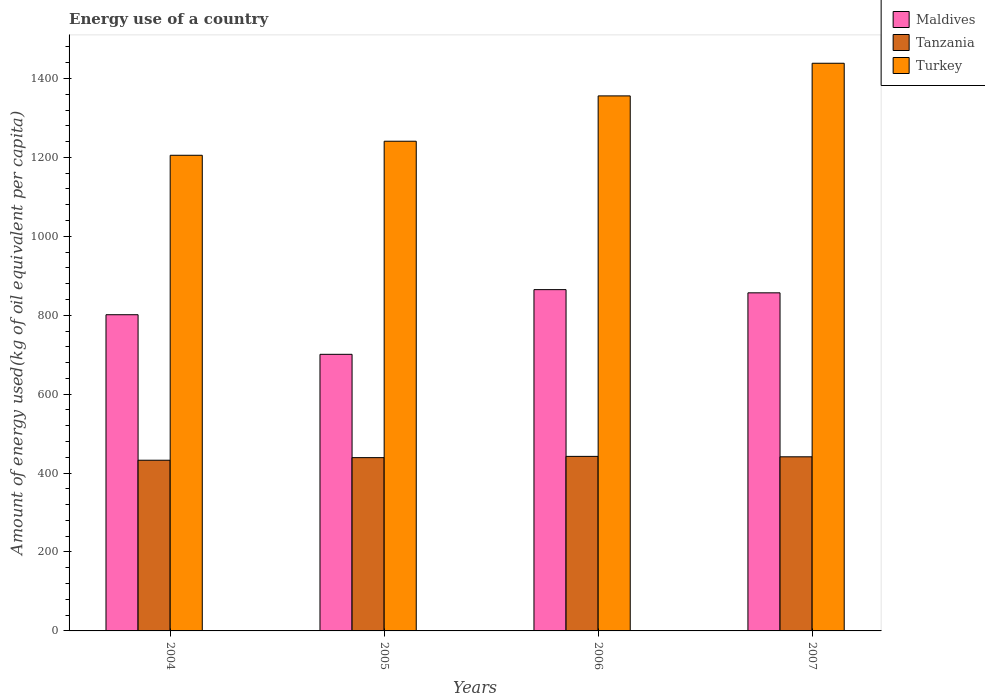How many different coloured bars are there?
Offer a very short reply. 3. How many groups of bars are there?
Ensure brevity in your answer.  4. Are the number of bars on each tick of the X-axis equal?
Provide a short and direct response. Yes. What is the label of the 2nd group of bars from the left?
Your response must be concise. 2005. What is the amount of energy used in in Tanzania in 2004?
Offer a very short reply. 432.58. Across all years, what is the maximum amount of energy used in in Turkey?
Give a very brief answer. 1438.52. Across all years, what is the minimum amount of energy used in in Turkey?
Ensure brevity in your answer.  1205.34. In which year was the amount of energy used in in Turkey maximum?
Make the answer very short. 2007. What is the total amount of energy used in in Maldives in the graph?
Offer a terse response. 3223.82. What is the difference between the amount of energy used in in Maldives in 2006 and that in 2007?
Give a very brief answer. 8.13. What is the difference between the amount of energy used in in Tanzania in 2007 and the amount of energy used in in Maldives in 2005?
Provide a succinct answer. -259.72. What is the average amount of energy used in in Maldives per year?
Give a very brief answer. 805.95. In the year 2005, what is the difference between the amount of energy used in in Maldives and amount of energy used in in Tanzania?
Make the answer very short. 261.8. In how many years, is the amount of energy used in in Turkey greater than 1040 kg?
Ensure brevity in your answer.  4. What is the ratio of the amount of energy used in in Turkey in 2006 to that in 2007?
Your response must be concise. 0.94. Is the amount of energy used in in Turkey in 2004 less than that in 2006?
Make the answer very short. Yes. Is the difference between the amount of energy used in in Maldives in 2004 and 2005 greater than the difference between the amount of energy used in in Tanzania in 2004 and 2005?
Your response must be concise. Yes. What is the difference between the highest and the second highest amount of energy used in in Tanzania?
Your response must be concise. 1.09. What is the difference between the highest and the lowest amount of energy used in in Turkey?
Provide a short and direct response. 233.18. In how many years, is the amount of energy used in in Turkey greater than the average amount of energy used in in Turkey taken over all years?
Provide a short and direct response. 2. What does the 2nd bar from the right in 2004 represents?
Offer a terse response. Tanzania. Is it the case that in every year, the sum of the amount of energy used in in Maldives and amount of energy used in in Turkey is greater than the amount of energy used in in Tanzania?
Make the answer very short. Yes. How many bars are there?
Keep it short and to the point. 12. Are all the bars in the graph horizontal?
Keep it short and to the point. No. Are the values on the major ticks of Y-axis written in scientific E-notation?
Provide a short and direct response. No. Does the graph contain any zero values?
Your answer should be very brief. No. Does the graph contain grids?
Keep it short and to the point. No. Where does the legend appear in the graph?
Offer a terse response. Top right. How are the legend labels stacked?
Make the answer very short. Vertical. What is the title of the graph?
Your response must be concise. Energy use of a country. Does "Senegal" appear as one of the legend labels in the graph?
Provide a short and direct response. No. What is the label or title of the X-axis?
Provide a short and direct response. Years. What is the label or title of the Y-axis?
Offer a terse response. Amount of energy used(kg of oil equivalent per capita). What is the Amount of energy used(kg of oil equivalent per capita) in Maldives in 2004?
Your answer should be compact. 801.28. What is the Amount of energy used(kg of oil equivalent per capita) of Tanzania in 2004?
Offer a terse response. 432.58. What is the Amount of energy used(kg of oil equivalent per capita) of Turkey in 2004?
Ensure brevity in your answer.  1205.34. What is the Amount of energy used(kg of oil equivalent per capita) in Maldives in 2005?
Ensure brevity in your answer.  700.93. What is the Amount of energy used(kg of oil equivalent per capita) of Tanzania in 2005?
Keep it short and to the point. 439.14. What is the Amount of energy used(kg of oil equivalent per capita) in Turkey in 2005?
Make the answer very short. 1240.95. What is the Amount of energy used(kg of oil equivalent per capita) in Maldives in 2006?
Offer a terse response. 864.86. What is the Amount of energy used(kg of oil equivalent per capita) in Tanzania in 2006?
Offer a terse response. 442.3. What is the Amount of energy used(kg of oil equivalent per capita) in Turkey in 2006?
Give a very brief answer. 1355.8. What is the Amount of energy used(kg of oil equivalent per capita) of Maldives in 2007?
Your response must be concise. 856.73. What is the Amount of energy used(kg of oil equivalent per capita) of Tanzania in 2007?
Your response must be concise. 441.21. What is the Amount of energy used(kg of oil equivalent per capita) of Turkey in 2007?
Your answer should be compact. 1438.52. Across all years, what is the maximum Amount of energy used(kg of oil equivalent per capita) in Maldives?
Ensure brevity in your answer.  864.86. Across all years, what is the maximum Amount of energy used(kg of oil equivalent per capita) of Tanzania?
Your answer should be compact. 442.3. Across all years, what is the maximum Amount of energy used(kg of oil equivalent per capita) of Turkey?
Your response must be concise. 1438.52. Across all years, what is the minimum Amount of energy used(kg of oil equivalent per capita) of Maldives?
Your answer should be very brief. 700.93. Across all years, what is the minimum Amount of energy used(kg of oil equivalent per capita) in Tanzania?
Ensure brevity in your answer.  432.58. Across all years, what is the minimum Amount of energy used(kg of oil equivalent per capita) in Turkey?
Offer a very short reply. 1205.34. What is the total Amount of energy used(kg of oil equivalent per capita) in Maldives in the graph?
Ensure brevity in your answer.  3223.82. What is the total Amount of energy used(kg of oil equivalent per capita) of Tanzania in the graph?
Your answer should be very brief. 1755.23. What is the total Amount of energy used(kg of oil equivalent per capita) in Turkey in the graph?
Your answer should be compact. 5240.61. What is the difference between the Amount of energy used(kg of oil equivalent per capita) of Maldives in 2004 and that in 2005?
Your answer should be compact. 100.35. What is the difference between the Amount of energy used(kg of oil equivalent per capita) of Tanzania in 2004 and that in 2005?
Your answer should be very brief. -6.56. What is the difference between the Amount of energy used(kg of oil equivalent per capita) in Turkey in 2004 and that in 2005?
Give a very brief answer. -35.61. What is the difference between the Amount of energy used(kg of oil equivalent per capita) of Maldives in 2004 and that in 2006?
Provide a short and direct response. -63.58. What is the difference between the Amount of energy used(kg of oil equivalent per capita) in Tanzania in 2004 and that in 2006?
Offer a terse response. -9.72. What is the difference between the Amount of energy used(kg of oil equivalent per capita) of Turkey in 2004 and that in 2006?
Offer a very short reply. -150.47. What is the difference between the Amount of energy used(kg of oil equivalent per capita) of Maldives in 2004 and that in 2007?
Ensure brevity in your answer.  -55.45. What is the difference between the Amount of energy used(kg of oil equivalent per capita) of Tanzania in 2004 and that in 2007?
Provide a succinct answer. -8.63. What is the difference between the Amount of energy used(kg of oil equivalent per capita) in Turkey in 2004 and that in 2007?
Offer a very short reply. -233.18. What is the difference between the Amount of energy used(kg of oil equivalent per capita) in Maldives in 2005 and that in 2006?
Provide a succinct answer. -163.93. What is the difference between the Amount of energy used(kg of oil equivalent per capita) in Tanzania in 2005 and that in 2006?
Your answer should be compact. -3.16. What is the difference between the Amount of energy used(kg of oil equivalent per capita) of Turkey in 2005 and that in 2006?
Your response must be concise. -114.86. What is the difference between the Amount of energy used(kg of oil equivalent per capita) of Maldives in 2005 and that in 2007?
Provide a succinct answer. -155.8. What is the difference between the Amount of energy used(kg of oil equivalent per capita) of Tanzania in 2005 and that in 2007?
Your response must be concise. -2.07. What is the difference between the Amount of energy used(kg of oil equivalent per capita) in Turkey in 2005 and that in 2007?
Provide a short and direct response. -197.57. What is the difference between the Amount of energy used(kg of oil equivalent per capita) of Maldives in 2006 and that in 2007?
Provide a short and direct response. 8.13. What is the difference between the Amount of energy used(kg of oil equivalent per capita) of Tanzania in 2006 and that in 2007?
Your response must be concise. 1.09. What is the difference between the Amount of energy used(kg of oil equivalent per capita) in Turkey in 2006 and that in 2007?
Make the answer very short. -82.71. What is the difference between the Amount of energy used(kg of oil equivalent per capita) in Maldives in 2004 and the Amount of energy used(kg of oil equivalent per capita) in Tanzania in 2005?
Keep it short and to the point. 362.14. What is the difference between the Amount of energy used(kg of oil equivalent per capita) of Maldives in 2004 and the Amount of energy used(kg of oil equivalent per capita) of Turkey in 2005?
Offer a very short reply. -439.67. What is the difference between the Amount of energy used(kg of oil equivalent per capita) of Tanzania in 2004 and the Amount of energy used(kg of oil equivalent per capita) of Turkey in 2005?
Offer a very short reply. -808.37. What is the difference between the Amount of energy used(kg of oil equivalent per capita) of Maldives in 2004 and the Amount of energy used(kg of oil equivalent per capita) of Tanzania in 2006?
Make the answer very short. 358.98. What is the difference between the Amount of energy used(kg of oil equivalent per capita) of Maldives in 2004 and the Amount of energy used(kg of oil equivalent per capita) of Turkey in 2006?
Provide a succinct answer. -554.52. What is the difference between the Amount of energy used(kg of oil equivalent per capita) of Tanzania in 2004 and the Amount of energy used(kg of oil equivalent per capita) of Turkey in 2006?
Ensure brevity in your answer.  -923.23. What is the difference between the Amount of energy used(kg of oil equivalent per capita) of Maldives in 2004 and the Amount of energy used(kg of oil equivalent per capita) of Tanzania in 2007?
Offer a very short reply. 360.07. What is the difference between the Amount of energy used(kg of oil equivalent per capita) of Maldives in 2004 and the Amount of energy used(kg of oil equivalent per capita) of Turkey in 2007?
Offer a very short reply. -637.23. What is the difference between the Amount of energy used(kg of oil equivalent per capita) of Tanzania in 2004 and the Amount of energy used(kg of oil equivalent per capita) of Turkey in 2007?
Provide a succinct answer. -1005.94. What is the difference between the Amount of energy used(kg of oil equivalent per capita) of Maldives in 2005 and the Amount of energy used(kg of oil equivalent per capita) of Tanzania in 2006?
Give a very brief answer. 258.64. What is the difference between the Amount of energy used(kg of oil equivalent per capita) of Maldives in 2005 and the Amount of energy used(kg of oil equivalent per capita) of Turkey in 2006?
Provide a short and direct response. -654.87. What is the difference between the Amount of energy used(kg of oil equivalent per capita) of Tanzania in 2005 and the Amount of energy used(kg of oil equivalent per capita) of Turkey in 2006?
Make the answer very short. -916.67. What is the difference between the Amount of energy used(kg of oil equivalent per capita) of Maldives in 2005 and the Amount of energy used(kg of oil equivalent per capita) of Tanzania in 2007?
Offer a terse response. 259.72. What is the difference between the Amount of energy used(kg of oil equivalent per capita) of Maldives in 2005 and the Amount of energy used(kg of oil equivalent per capita) of Turkey in 2007?
Provide a succinct answer. -737.58. What is the difference between the Amount of energy used(kg of oil equivalent per capita) in Tanzania in 2005 and the Amount of energy used(kg of oil equivalent per capita) in Turkey in 2007?
Your answer should be very brief. -999.38. What is the difference between the Amount of energy used(kg of oil equivalent per capita) in Maldives in 2006 and the Amount of energy used(kg of oil equivalent per capita) in Tanzania in 2007?
Your answer should be very brief. 423.65. What is the difference between the Amount of energy used(kg of oil equivalent per capita) of Maldives in 2006 and the Amount of energy used(kg of oil equivalent per capita) of Turkey in 2007?
Offer a terse response. -573.65. What is the difference between the Amount of energy used(kg of oil equivalent per capita) in Tanzania in 2006 and the Amount of energy used(kg of oil equivalent per capita) in Turkey in 2007?
Your response must be concise. -996.22. What is the average Amount of energy used(kg of oil equivalent per capita) in Maldives per year?
Ensure brevity in your answer.  805.95. What is the average Amount of energy used(kg of oil equivalent per capita) in Tanzania per year?
Your response must be concise. 438.81. What is the average Amount of energy used(kg of oil equivalent per capita) in Turkey per year?
Your answer should be compact. 1310.15. In the year 2004, what is the difference between the Amount of energy used(kg of oil equivalent per capita) in Maldives and Amount of energy used(kg of oil equivalent per capita) in Tanzania?
Provide a succinct answer. 368.7. In the year 2004, what is the difference between the Amount of energy used(kg of oil equivalent per capita) in Maldives and Amount of energy used(kg of oil equivalent per capita) in Turkey?
Keep it short and to the point. -404.06. In the year 2004, what is the difference between the Amount of energy used(kg of oil equivalent per capita) of Tanzania and Amount of energy used(kg of oil equivalent per capita) of Turkey?
Your answer should be compact. -772.76. In the year 2005, what is the difference between the Amount of energy used(kg of oil equivalent per capita) in Maldives and Amount of energy used(kg of oil equivalent per capita) in Tanzania?
Provide a succinct answer. 261.8. In the year 2005, what is the difference between the Amount of energy used(kg of oil equivalent per capita) of Maldives and Amount of energy used(kg of oil equivalent per capita) of Turkey?
Offer a very short reply. -540.01. In the year 2005, what is the difference between the Amount of energy used(kg of oil equivalent per capita) of Tanzania and Amount of energy used(kg of oil equivalent per capita) of Turkey?
Make the answer very short. -801.81. In the year 2006, what is the difference between the Amount of energy used(kg of oil equivalent per capita) in Maldives and Amount of energy used(kg of oil equivalent per capita) in Tanzania?
Give a very brief answer. 422.57. In the year 2006, what is the difference between the Amount of energy used(kg of oil equivalent per capita) of Maldives and Amount of energy used(kg of oil equivalent per capita) of Turkey?
Provide a short and direct response. -490.94. In the year 2006, what is the difference between the Amount of energy used(kg of oil equivalent per capita) of Tanzania and Amount of energy used(kg of oil equivalent per capita) of Turkey?
Provide a succinct answer. -913.5. In the year 2007, what is the difference between the Amount of energy used(kg of oil equivalent per capita) of Maldives and Amount of energy used(kg of oil equivalent per capita) of Tanzania?
Offer a terse response. 415.52. In the year 2007, what is the difference between the Amount of energy used(kg of oil equivalent per capita) in Maldives and Amount of energy used(kg of oil equivalent per capita) in Turkey?
Ensure brevity in your answer.  -581.78. In the year 2007, what is the difference between the Amount of energy used(kg of oil equivalent per capita) in Tanzania and Amount of energy used(kg of oil equivalent per capita) in Turkey?
Make the answer very short. -997.31. What is the ratio of the Amount of energy used(kg of oil equivalent per capita) in Maldives in 2004 to that in 2005?
Your answer should be compact. 1.14. What is the ratio of the Amount of energy used(kg of oil equivalent per capita) in Tanzania in 2004 to that in 2005?
Ensure brevity in your answer.  0.99. What is the ratio of the Amount of energy used(kg of oil equivalent per capita) in Turkey in 2004 to that in 2005?
Provide a short and direct response. 0.97. What is the ratio of the Amount of energy used(kg of oil equivalent per capita) in Maldives in 2004 to that in 2006?
Keep it short and to the point. 0.93. What is the ratio of the Amount of energy used(kg of oil equivalent per capita) of Tanzania in 2004 to that in 2006?
Ensure brevity in your answer.  0.98. What is the ratio of the Amount of energy used(kg of oil equivalent per capita) of Turkey in 2004 to that in 2006?
Your answer should be very brief. 0.89. What is the ratio of the Amount of energy used(kg of oil equivalent per capita) in Maldives in 2004 to that in 2007?
Provide a short and direct response. 0.94. What is the ratio of the Amount of energy used(kg of oil equivalent per capita) of Tanzania in 2004 to that in 2007?
Your answer should be very brief. 0.98. What is the ratio of the Amount of energy used(kg of oil equivalent per capita) of Turkey in 2004 to that in 2007?
Offer a very short reply. 0.84. What is the ratio of the Amount of energy used(kg of oil equivalent per capita) of Maldives in 2005 to that in 2006?
Provide a succinct answer. 0.81. What is the ratio of the Amount of energy used(kg of oil equivalent per capita) of Tanzania in 2005 to that in 2006?
Provide a succinct answer. 0.99. What is the ratio of the Amount of energy used(kg of oil equivalent per capita) in Turkey in 2005 to that in 2006?
Ensure brevity in your answer.  0.92. What is the ratio of the Amount of energy used(kg of oil equivalent per capita) in Maldives in 2005 to that in 2007?
Offer a terse response. 0.82. What is the ratio of the Amount of energy used(kg of oil equivalent per capita) in Tanzania in 2005 to that in 2007?
Your answer should be compact. 1. What is the ratio of the Amount of energy used(kg of oil equivalent per capita) in Turkey in 2005 to that in 2007?
Ensure brevity in your answer.  0.86. What is the ratio of the Amount of energy used(kg of oil equivalent per capita) in Maldives in 2006 to that in 2007?
Your response must be concise. 1.01. What is the ratio of the Amount of energy used(kg of oil equivalent per capita) in Tanzania in 2006 to that in 2007?
Give a very brief answer. 1. What is the ratio of the Amount of energy used(kg of oil equivalent per capita) of Turkey in 2006 to that in 2007?
Keep it short and to the point. 0.94. What is the difference between the highest and the second highest Amount of energy used(kg of oil equivalent per capita) of Maldives?
Your answer should be compact. 8.13. What is the difference between the highest and the second highest Amount of energy used(kg of oil equivalent per capita) of Tanzania?
Provide a short and direct response. 1.09. What is the difference between the highest and the second highest Amount of energy used(kg of oil equivalent per capita) in Turkey?
Offer a very short reply. 82.71. What is the difference between the highest and the lowest Amount of energy used(kg of oil equivalent per capita) of Maldives?
Provide a succinct answer. 163.93. What is the difference between the highest and the lowest Amount of energy used(kg of oil equivalent per capita) in Tanzania?
Offer a terse response. 9.72. What is the difference between the highest and the lowest Amount of energy used(kg of oil equivalent per capita) in Turkey?
Offer a terse response. 233.18. 